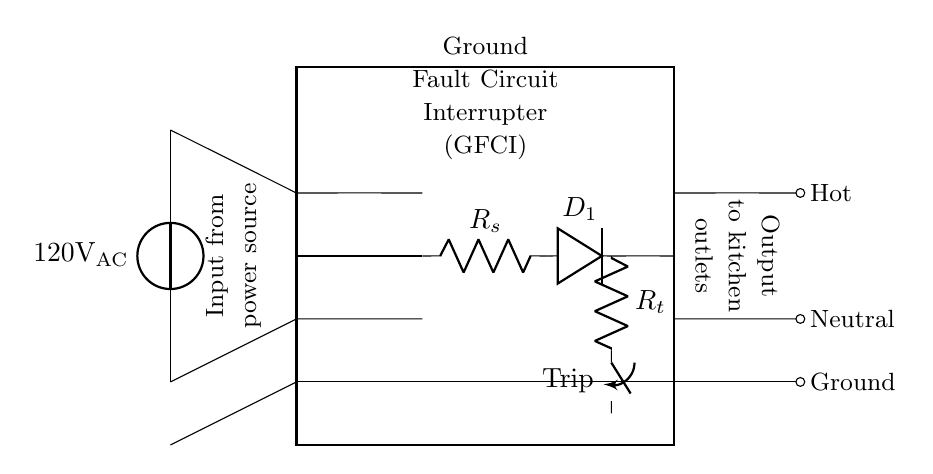What is the voltage of this circuit? The circuit diagram shows a power source labeled as 120 volts AC, which indicates the voltage supplied to the circuit.
Answer: 120 volts AC What does the rectangular box represent? The thick rectangle in the circuit diagram is labeled "Ground Fault Circuit Interrupter (GFCI)," indicating that this component is responsible for protecting against ground faults.
Answer: Ground Fault Circuit Interrupter (GFCI) What component senses differential current? The diagram includes a transformer core that connects to the sensing circuit, indicating that it is the component used to sense the differential current flowing through the circuit.
Answer: Transformer core What is the purpose of the trip mechanism? Within the GFCI, there is a trip mechanism connected to a resistor and switch, which functions to disconnect the circuit upon detecting an imbalance in current, thus providing protection from electric shock.
Answer: Disconnects the circuit What is the output voltage of the GFCI to the kitchen outlets? The GFCI's output connects to the kitchen outlets as hot, neutral, and ground, effectively allowing the same voltage (120 volts AC) applied to the GFCI to be supplied to the outlets.
Answer: 120 volts AC How many wires are present in the output to the kitchen outlets? The diagram shows three separate outputs: hot, neutral, and ground, indicating that there are three wires running from the GFCI to the kitchen outlets.
Answer: Three wires What type of circuit does this arrangement represent? The arrangement depicted in the circuit diagram is a safety protection circuit specifically designed to prevent electrical hazards, commonly categorized as a ground fault protection circuit.
Answer: Ground fault protection circuit 